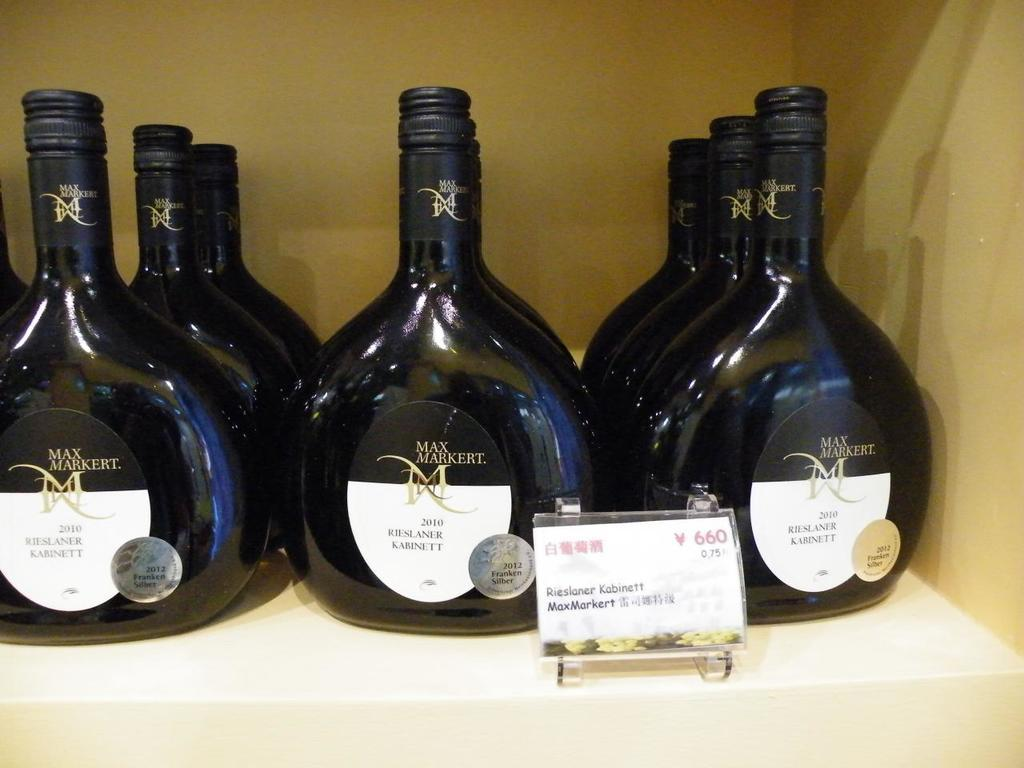Provide a one-sentence caption for the provided image. A Shelf containing Max Markert wine is on display. 